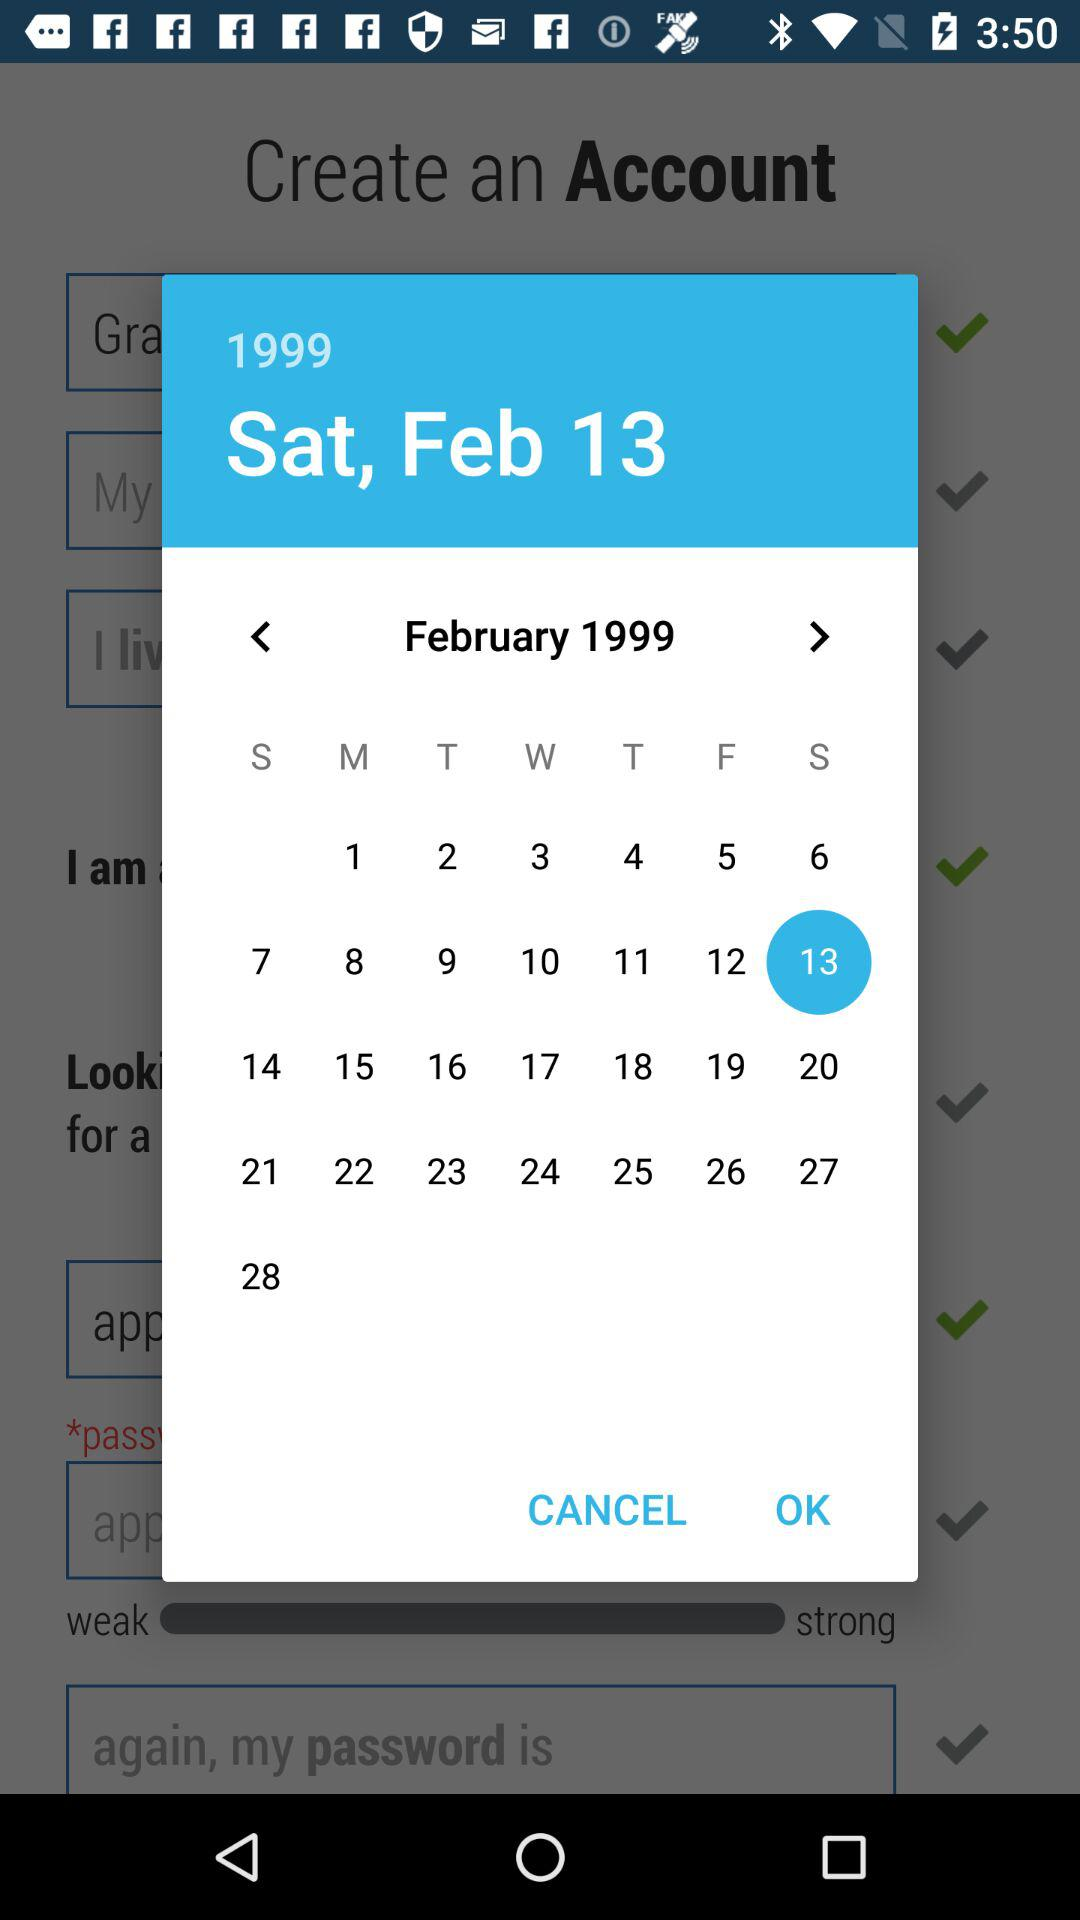What day is it on February 13, 1999? The day is Saturday. 